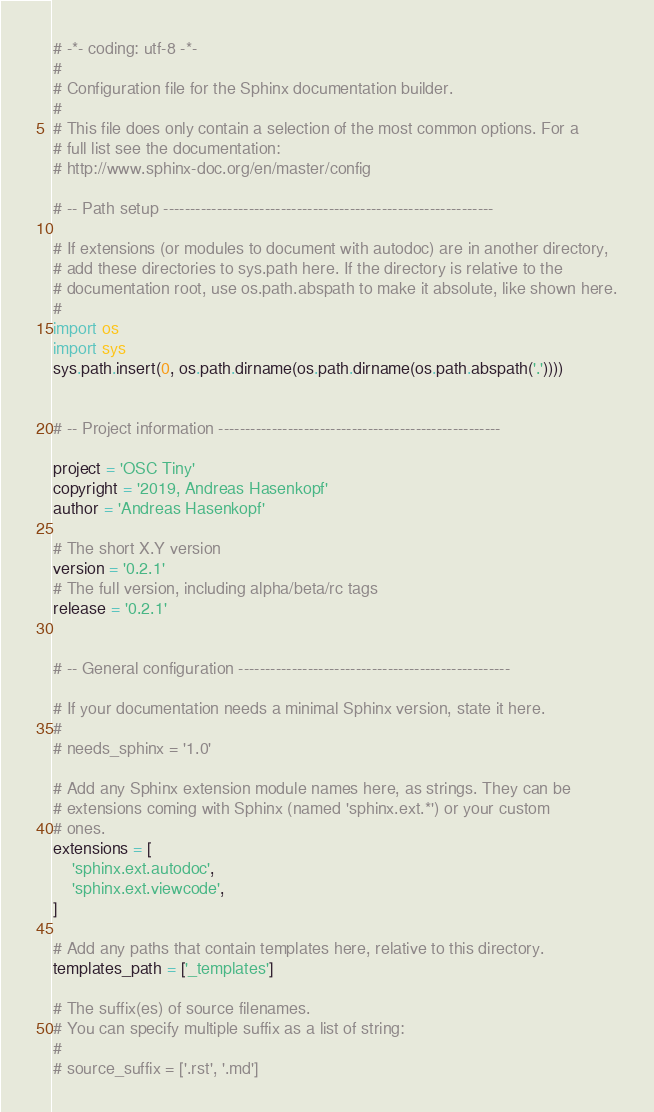Convert code to text. <code><loc_0><loc_0><loc_500><loc_500><_Python_># -*- coding: utf-8 -*-
#
# Configuration file for the Sphinx documentation builder.
#
# This file does only contain a selection of the most common options. For a
# full list see the documentation:
# http://www.sphinx-doc.org/en/master/config

# -- Path setup --------------------------------------------------------------

# If extensions (or modules to document with autodoc) are in another directory,
# add these directories to sys.path here. If the directory is relative to the
# documentation root, use os.path.abspath to make it absolute, like shown here.
#
import os
import sys
sys.path.insert(0, os.path.dirname(os.path.dirname(os.path.abspath('.'))))


# -- Project information -----------------------------------------------------

project = 'OSC Tiny'
copyright = '2019, Andreas Hasenkopf'
author = 'Andreas Hasenkopf'

# The short X.Y version
version = '0.2.1'
# The full version, including alpha/beta/rc tags
release = '0.2.1'


# -- General configuration ---------------------------------------------------

# If your documentation needs a minimal Sphinx version, state it here.
#
# needs_sphinx = '1.0'

# Add any Sphinx extension module names here, as strings. They can be
# extensions coming with Sphinx (named 'sphinx.ext.*') or your custom
# ones.
extensions = [
    'sphinx.ext.autodoc',
    'sphinx.ext.viewcode',
]

# Add any paths that contain templates here, relative to this directory.
templates_path = ['_templates']

# The suffix(es) of source filenames.
# You can specify multiple suffix as a list of string:
#
# source_suffix = ['.rst', '.md']</code> 